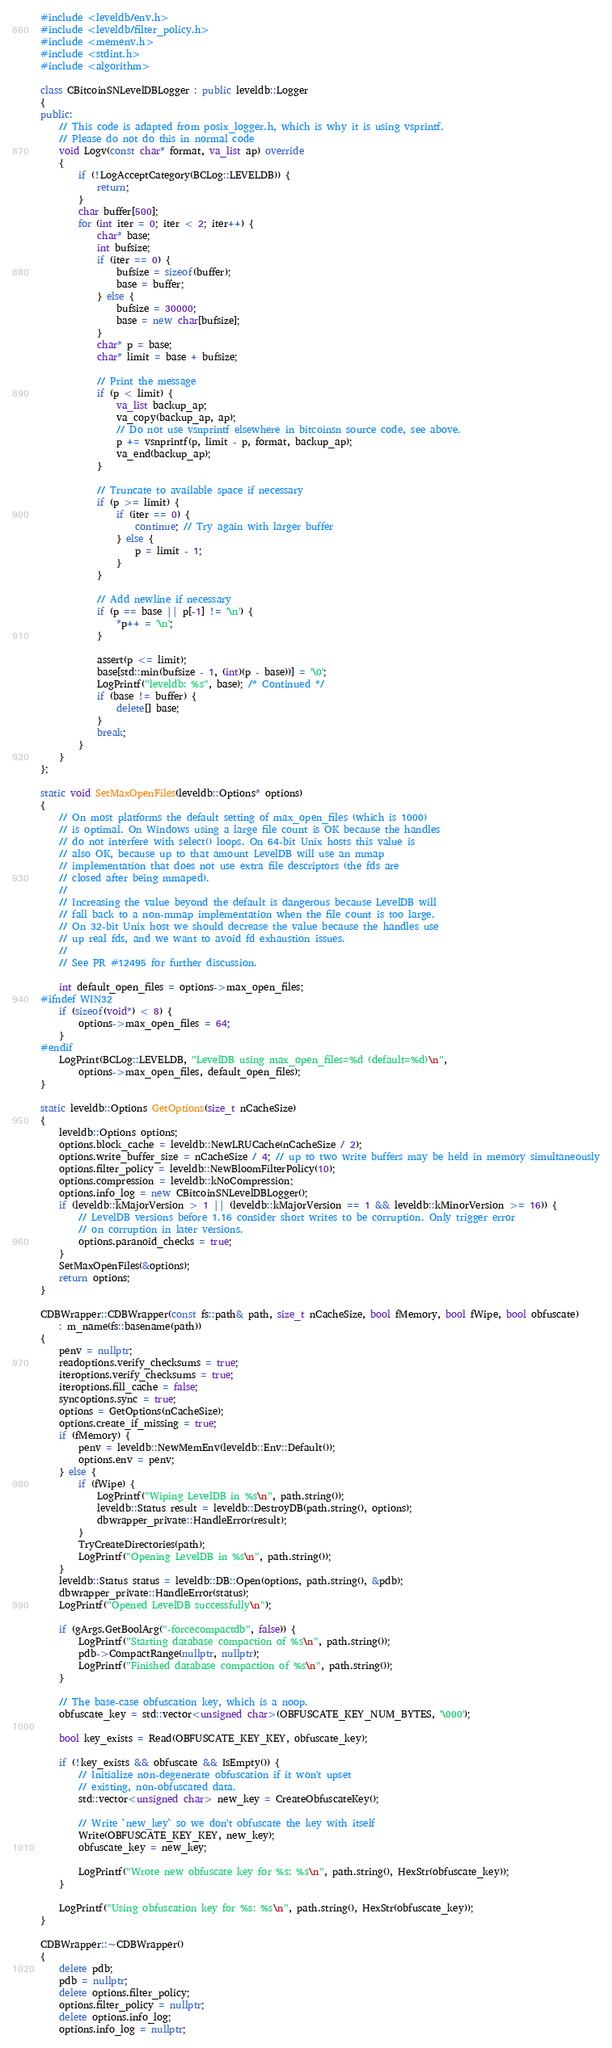Convert code to text. <code><loc_0><loc_0><loc_500><loc_500><_C++_>#include <leveldb/env.h>
#include <leveldb/filter_policy.h>
#include <memenv.h>
#include <stdint.h>
#include <algorithm>

class CBitcoinSNLevelDBLogger : public leveldb::Logger
{
public:
    // This code is adapted from posix_logger.h, which is why it is using vsprintf.
    // Please do not do this in normal code
    void Logv(const char* format, va_list ap) override
    {
        if (!LogAcceptCategory(BCLog::LEVELDB)) {
            return;
        }
        char buffer[500];
        for (int iter = 0; iter < 2; iter++) {
            char* base;
            int bufsize;
            if (iter == 0) {
                bufsize = sizeof(buffer);
                base = buffer;
            } else {
                bufsize = 30000;
                base = new char[bufsize];
            }
            char* p = base;
            char* limit = base + bufsize;

            // Print the message
            if (p < limit) {
                va_list backup_ap;
                va_copy(backup_ap, ap);
                // Do not use vsnprintf elsewhere in bitcoinsn source code, see above.
                p += vsnprintf(p, limit - p, format, backup_ap);
                va_end(backup_ap);
            }

            // Truncate to available space if necessary
            if (p >= limit) {
                if (iter == 0) {
                    continue; // Try again with larger buffer
                } else {
                    p = limit - 1;
                }
            }

            // Add newline if necessary
            if (p == base || p[-1] != '\n') {
                *p++ = '\n';
            }

            assert(p <= limit);
            base[std::min(bufsize - 1, (int)(p - base))] = '\0';
            LogPrintf("leveldb: %s", base); /* Continued */
            if (base != buffer) {
                delete[] base;
            }
            break;
        }
    }
};

static void SetMaxOpenFiles(leveldb::Options* options)
{
    // On most platforms the default setting of max_open_files (which is 1000)
    // is optimal. On Windows using a large file count is OK because the handles
    // do not interfere with select() loops. On 64-bit Unix hosts this value is
    // also OK, because up to that amount LevelDB will use an mmap
    // implementation that does not use extra file descriptors (the fds are
    // closed after being mmaped).
    //
    // Increasing the value beyond the default is dangerous because LevelDB will
    // fall back to a non-mmap implementation when the file count is too large.
    // On 32-bit Unix host we should decrease the value because the handles use
    // up real fds, and we want to avoid fd exhaustion issues.
    //
    // See PR #12495 for further discussion.

    int default_open_files = options->max_open_files;
#ifndef WIN32
    if (sizeof(void*) < 8) {
        options->max_open_files = 64;
    }
#endif
    LogPrint(BCLog::LEVELDB, "LevelDB using max_open_files=%d (default=%d)\n",
        options->max_open_files, default_open_files);
}

static leveldb::Options GetOptions(size_t nCacheSize)
{
    leveldb::Options options;
    options.block_cache = leveldb::NewLRUCache(nCacheSize / 2);
    options.write_buffer_size = nCacheSize / 4; // up to two write buffers may be held in memory simultaneously
    options.filter_policy = leveldb::NewBloomFilterPolicy(10);
    options.compression = leveldb::kNoCompression;
    options.info_log = new CBitcoinSNLevelDBLogger();
    if (leveldb::kMajorVersion > 1 || (leveldb::kMajorVersion == 1 && leveldb::kMinorVersion >= 16)) {
        // LevelDB versions before 1.16 consider short writes to be corruption. Only trigger error
        // on corruption in later versions.
        options.paranoid_checks = true;
    }
    SetMaxOpenFiles(&options);
    return options;
}

CDBWrapper::CDBWrapper(const fs::path& path, size_t nCacheSize, bool fMemory, bool fWipe, bool obfuscate)
    : m_name(fs::basename(path))
{
    penv = nullptr;
    readoptions.verify_checksums = true;
    iteroptions.verify_checksums = true;
    iteroptions.fill_cache = false;
    syncoptions.sync = true;
    options = GetOptions(nCacheSize);
    options.create_if_missing = true;
    if (fMemory) {
        penv = leveldb::NewMemEnv(leveldb::Env::Default());
        options.env = penv;
    } else {
        if (fWipe) {
            LogPrintf("Wiping LevelDB in %s\n", path.string());
            leveldb::Status result = leveldb::DestroyDB(path.string(), options);
            dbwrapper_private::HandleError(result);
        }
        TryCreateDirectories(path);
        LogPrintf("Opening LevelDB in %s\n", path.string());
    }
    leveldb::Status status = leveldb::DB::Open(options, path.string(), &pdb);
    dbwrapper_private::HandleError(status);
    LogPrintf("Opened LevelDB successfully\n");

    if (gArgs.GetBoolArg("-forcecompactdb", false)) {
        LogPrintf("Starting database compaction of %s\n", path.string());
        pdb->CompactRange(nullptr, nullptr);
        LogPrintf("Finished database compaction of %s\n", path.string());
    }

    // The base-case obfuscation key, which is a noop.
    obfuscate_key = std::vector<unsigned char>(OBFUSCATE_KEY_NUM_BYTES, '\000');

    bool key_exists = Read(OBFUSCATE_KEY_KEY, obfuscate_key);

    if (!key_exists && obfuscate && IsEmpty()) {
        // Initialize non-degenerate obfuscation if it won't upset
        // existing, non-obfuscated data.
        std::vector<unsigned char> new_key = CreateObfuscateKey();

        // Write `new_key` so we don't obfuscate the key with itself
        Write(OBFUSCATE_KEY_KEY, new_key);
        obfuscate_key = new_key;

        LogPrintf("Wrote new obfuscate key for %s: %s\n", path.string(), HexStr(obfuscate_key));
    }

    LogPrintf("Using obfuscation key for %s: %s\n", path.string(), HexStr(obfuscate_key));
}

CDBWrapper::~CDBWrapper()
{
    delete pdb;
    pdb = nullptr;
    delete options.filter_policy;
    options.filter_policy = nullptr;
    delete options.info_log;
    options.info_log = nullptr;</code> 